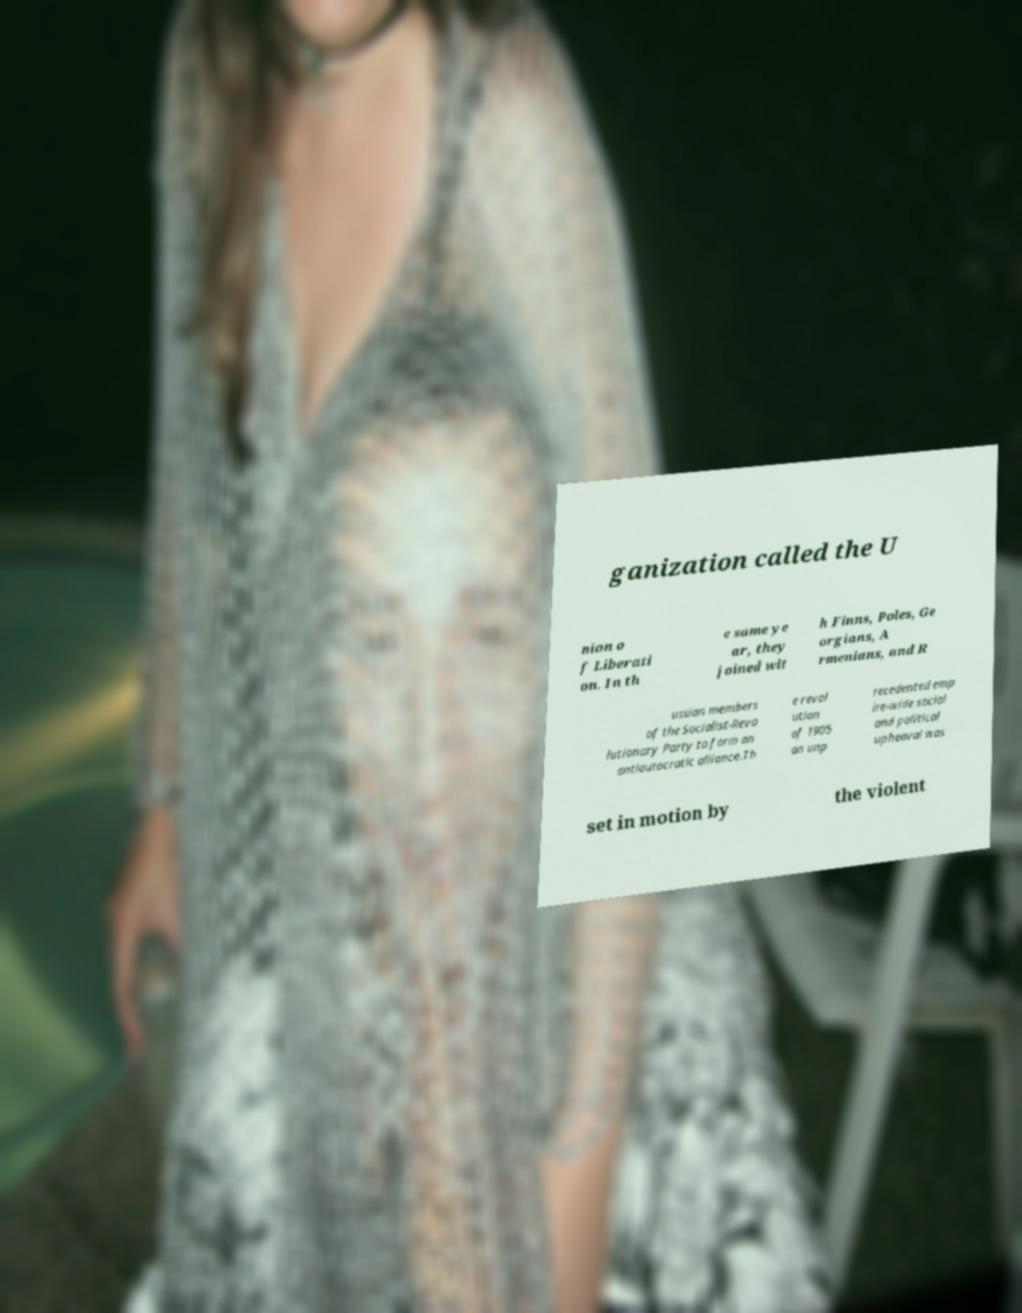Could you assist in decoding the text presented in this image and type it out clearly? ganization called the U nion o f Liberati on. In th e same ye ar, they joined wit h Finns, Poles, Ge orgians, A rmenians, and R ussian members of the Socialist-Revo lutionary Party to form an antiautocratic alliance.Th e revol ution of 1905 an unp recedented emp ire-wide social and political upheaval was set in motion by the violent 